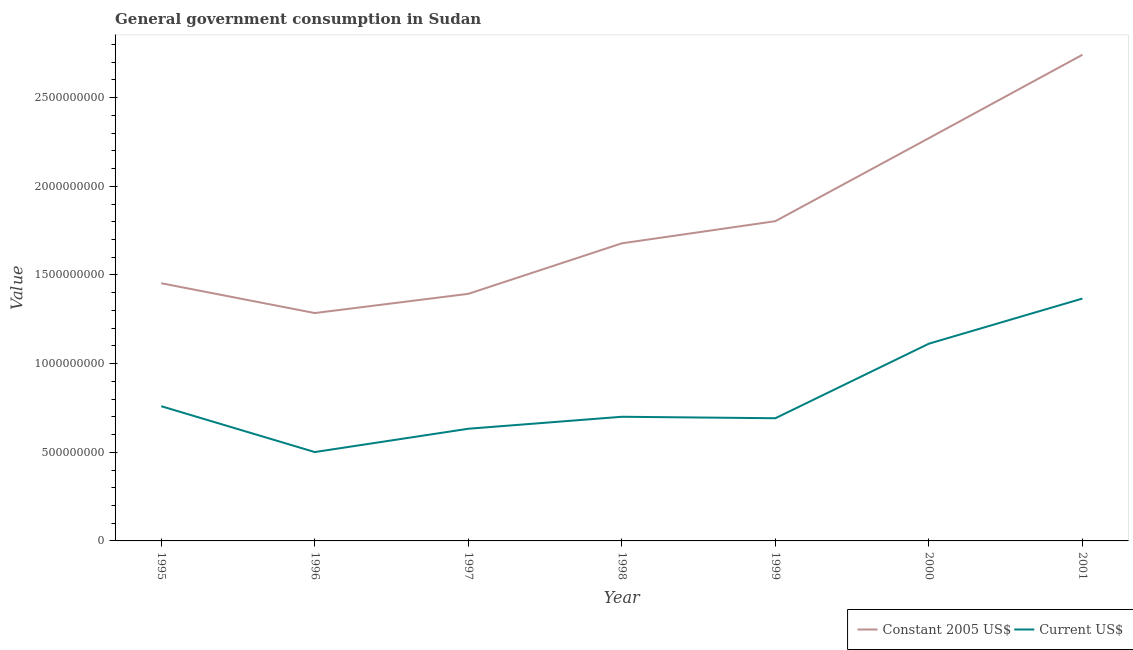How many different coloured lines are there?
Offer a terse response. 2. Does the line corresponding to value consumed in constant 2005 us$ intersect with the line corresponding to value consumed in current us$?
Ensure brevity in your answer.  No. What is the value consumed in current us$ in 1998?
Make the answer very short. 7.00e+08. Across all years, what is the maximum value consumed in current us$?
Your answer should be very brief. 1.37e+09. Across all years, what is the minimum value consumed in current us$?
Provide a short and direct response. 5.01e+08. In which year was the value consumed in current us$ maximum?
Ensure brevity in your answer.  2001. In which year was the value consumed in current us$ minimum?
Provide a short and direct response. 1996. What is the total value consumed in current us$ in the graph?
Your response must be concise. 5.77e+09. What is the difference between the value consumed in constant 2005 us$ in 1998 and that in 2001?
Your answer should be very brief. -1.06e+09. What is the difference between the value consumed in constant 2005 us$ in 1999 and the value consumed in current us$ in 1995?
Offer a very short reply. 1.04e+09. What is the average value consumed in current us$ per year?
Your response must be concise. 8.24e+08. In the year 1998, what is the difference between the value consumed in current us$ and value consumed in constant 2005 us$?
Provide a short and direct response. -9.78e+08. What is the ratio of the value consumed in current us$ in 1996 to that in 2001?
Offer a very short reply. 0.37. Is the difference between the value consumed in current us$ in 1995 and 1997 greater than the difference between the value consumed in constant 2005 us$ in 1995 and 1997?
Your response must be concise. Yes. What is the difference between the highest and the second highest value consumed in current us$?
Offer a terse response. 2.54e+08. What is the difference between the highest and the lowest value consumed in current us$?
Give a very brief answer. 8.66e+08. In how many years, is the value consumed in constant 2005 us$ greater than the average value consumed in constant 2005 us$ taken over all years?
Your answer should be compact. 2. Does the value consumed in constant 2005 us$ monotonically increase over the years?
Keep it short and to the point. No. Is the value consumed in current us$ strictly greater than the value consumed in constant 2005 us$ over the years?
Your response must be concise. No. How many lines are there?
Ensure brevity in your answer.  2. Does the graph contain any zero values?
Your answer should be very brief. No. How many legend labels are there?
Your answer should be compact. 2. How are the legend labels stacked?
Offer a terse response. Horizontal. What is the title of the graph?
Your answer should be compact. General government consumption in Sudan. What is the label or title of the Y-axis?
Keep it short and to the point. Value. What is the Value in Constant 2005 US$ in 1995?
Provide a short and direct response. 1.45e+09. What is the Value in Current US$ in 1995?
Make the answer very short. 7.60e+08. What is the Value of Constant 2005 US$ in 1996?
Keep it short and to the point. 1.29e+09. What is the Value in Current US$ in 1996?
Provide a succinct answer. 5.01e+08. What is the Value of Constant 2005 US$ in 1997?
Provide a short and direct response. 1.39e+09. What is the Value of Current US$ in 1997?
Offer a very short reply. 6.33e+08. What is the Value of Constant 2005 US$ in 1998?
Give a very brief answer. 1.68e+09. What is the Value in Current US$ in 1998?
Provide a succinct answer. 7.00e+08. What is the Value of Constant 2005 US$ in 1999?
Provide a short and direct response. 1.80e+09. What is the Value in Current US$ in 1999?
Ensure brevity in your answer.  6.92e+08. What is the Value in Constant 2005 US$ in 2000?
Give a very brief answer. 2.27e+09. What is the Value in Current US$ in 2000?
Give a very brief answer. 1.11e+09. What is the Value in Constant 2005 US$ in 2001?
Offer a terse response. 2.74e+09. What is the Value of Current US$ in 2001?
Your response must be concise. 1.37e+09. Across all years, what is the maximum Value of Constant 2005 US$?
Provide a short and direct response. 2.74e+09. Across all years, what is the maximum Value in Current US$?
Ensure brevity in your answer.  1.37e+09. Across all years, what is the minimum Value of Constant 2005 US$?
Your answer should be very brief. 1.29e+09. Across all years, what is the minimum Value in Current US$?
Your response must be concise. 5.01e+08. What is the total Value of Constant 2005 US$ in the graph?
Your answer should be compact. 1.26e+1. What is the total Value in Current US$ in the graph?
Give a very brief answer. 5.77e+09. What is the difference between the Value in Constant 2005 US$ in 1995 and that in 1996?
Provide a short and direct response. 1.68e+08. What is the difference between the Value in Current US$ in 1995 and that in 1996?
Your answer should be compact. 2.59e+08. What is the difference between the Value in Constant 2005 US$ in 1995 and that in 1997?
Your answer should be very brief. 5.98e+07. What is the difference between the Value in Current US$ in 1995 and that in 1997?
Keep it short and to the point. 1.27e+08. What is the difference between the Value in Constant 2005 US$ in 1995 and that in 1998?
Give a very brief answer. -2.25e+08. What is the difference between the Value in Current US$ in 1995 and that in 1998?
Your response must be concise. 5.95e+07. What is the difference between the Value in Constant 2005 US$ in 1995 and that in 1999?
Your response must be concise. -3.50e+08. What is the difference between the Value of Current US$ in 1995 and that in 1999?
Offer a very short reply. 6.78e+07. What is the difference between the Value of Constant 2005 US$ in 1995 and that in 2000?
Make the answer very short. -8.18e+08. What is the difference between the Value in Current US$ in 1995 and that in 2000?
Ensure brevity in your answer.  -3.53e+08. What is the difference between the Value of Constant 2005 US$ in 1995 and that in 2001?
Give a very brief answer. -1.29e+09. What is the difference between the Value in Current US$ in 1995 and that in 2001?
Your answer should be compact. -6.07e+08. What is the difference between the Value in Constant 2005 US$ in 1996 and that in 1997?
Provide a succinct answer. -1.08e+08. What is the difference between the Value in Current US$ in 1996 and that in 1997?
Provide a short and direct response. -1.31e+08. What is the difference between the Value in Constant 2005 US$ in 1996 and that in 1998?
Make the answer very short. -3.93e+08. What is the difference between the Value of Current US$ in 1996 and that in 1998?
Keep it short and to the point. -1.99e+08. What is the difference between the Value of Constant 2005 US$ in 1996 and that in 1999?
Keep it short and to the point. -5.18e+08. What is the difference between the Value in Current US$ in 1996 and that in 1999?
Your answer should be very brief. -1.91e+08. What is the difference between the Value of Constant 2005 US$ in 1996 and that in 2000?
Keep it short and to the point. -9.87e+08. What is the difference between the Value in Current US$ in 1996 and that in 2000?
Make the answer very short. -6.11e+08. What is the difference between the Value in Constant 2005 US$ in 1996 and that in 2001?
Your answer should be compact. -1.46e+09. What is the difference between the Value of Current US$ in 1996 and that in 2001?
Offer a very short reply. -8.66e+08. What is the difference between the Value in Constant 2005 US$ in 1997 and that in 1998?
Ensure brevity in your answer.  -2.85e+08. What is the difference between the Value in Current US$ in 1997 and that in 1998?
Your answer should be compact. -6.76e+07. What is the difference between the Value in Constant 2005 US$ in 1997 and that in 1999?
Provide a succinct answer. -4.10e+08. What is the difference between the Value in Current US$ in 1997 and that in 1999?
Give a very brief answer. -5.93e+07. What is the difference between the Value in Constant 2005 US$ in 1997 and that in 2000?
Offer a terse response. -8.78e+08. What is the difference between the Value in Current US$ in 1997 and that in 2000?
Keep it short and to the point. -4.80e+08. What is the difference between the Value in Constant 2005 US$ in 1997 and that in 2001?
Give a very brief answer. -1.35e+09. What is the difference between the Value in Current US$ in 1997 and that in 2001?
Make the answer very short. -7.34e+08. What is the difference between the Value of Constant 2005 US$ in 1998 and that in 1999?
Offer a very short reply. -1.25e+08. What is the difference between the Value in Current US$ in 1998 and that in 1999?
Your answer should be very brief. 8.26e+06. What is the difference between the Value in Constant 2005 US$ in 1998 and that in 2000?
Offer a terse response. -5.93e+08. What is the difference between the Value in Current US$ in 1998 and that in 2000?
Your response must be concise. -4.12e+08. What is the difference between the Value of Constant 2005 US$ in 1998 and that in 2001?
Ensure brevity in your answer.  -1.06e+09. What is the difference between the Value of Current US$ in 1998 and that in 2001?
Give a very brief answer. -6.67e+08. What is the difference between the Value in Constant 2005 US$ in 1999 and that in 2000?
Your response must be concise. -4.68e+08. What is the difference between the Value of Current US$ in 1999 and that in 2000?
Offer a terse response. -4.21e+08. What is the difference between the Value in Constant 2005 US$ in 1999 and that in 2001?
Your answer should be very brief. -9.39e+08. What is the difference between the Value in Current US$ in 1999 and that in 2001?
Provide a succinct answer. -6.75e+08. What is the difference between the Value in Constant 2005 US$ in 2000 and that in 2001?
Offer a terse response. -4.70e+08. What is the difference between the Value in Current US$ in 2000 and that in 2001?
Keep it short and to the point. -2.54e+08. What is the difference between the Value of Constant 2005 US$ in 1995 and the Value of Current US$ in 1996?
Offer a terse response. 9.52e+08. What is the difference between the Value in Constant 2005 US$ in 1995 and the Value in Current US$ in 1997?
Give a very brief answer. 8.21e+08. What is the difference between the Value in Constant 2005 US$ in 1995 and the Value in Current US$ in 1998?
Offer a very short reply. 7.53e+08. What is the difference between the Value of Constant 2005 US$ in 1995 and the Value of Current US$ in 1999?
Your response must be concise. 7.61e+08. What is the difference between the Value of Constant 2005 US$ in 1995 and the Value of Current US$ in 2000?
Provide a short and direct response. 3.41e+08. What is the difference between the Value of Constant 2005 US$ in 1995 and the Value of Current US$ in 2001?
Offer a terse response. 8.64e+07. What is the difference between the Value of Constant 2005 US$ in 1996 and the Value of Current US$ in 1997?
Your answer should be compact. 6.53e+08. What is the difference between the Value in Constant 2005 US$ in 1996 and the Value in Current US$ in 1998?
Provide a short and direct response. 5.85e+08. What is the difference between the Value in Constant 2005 US$ in 1996 and the Value in Current US$ in 1999?
Offer a very short reply. 5.93e+08. What is the difference between the Value in Constant 2005 US$ in 1996 and the Value in Current US$ in 2000?
Offer a very short reply. 1.73e+08. What is the difference between the Value of Constant 2005 US$ in 1996 and the Value of Current US$ in 2001?
Provide a short and direct response. -8.18e+07. What is the difference between the Value in Constant 2005 US$ in 1997 and the Value in Current US$ in 1998?
Your answer should be compact. 6.93e+08. What is the difference between the Value in Constant 2005 US$ in 1997 and the Value in Current US$ in 1999?
Offer a very short reply. 7.02e+08. What is the difference between the Value in Constant 2005 US$ in 1997 and the Value in Current US$ in 2000?
Your answer should be compact. 2.81e+08. What is the difference between the Value of Constant 2005 US$ in 1997 and the Value of Current US$ in 2001?
Provide a succinct answer. 2.65e+07. What is the difference between the Value of Constant 2005 US$ in 1998 and the Value of Current US$ in 1999?
Offer a very short reply. 9.87e+08. What is the difference between the Value in Constant 2005 US$ in 1998 and the Value in Current US$ in 2000?
Provide a short and direct response. 5.66e+08. What is the difference between the Value of Constant 2005 US$ in 1998 and the Value of Current US$ in 2001?
Keep it short and to the point. 3.11e+08. What is the difference between the Value in Constant 2005 US$ in 1999 and the Value in Current US$ in 2000?
Ensure brevity in your answer.  6.91e+08. What is the difference between the Value of Constant 2005 US$ in 1999 and the Value of Current US$ in 2001?
Your response must be concise. 4.36e+08. What is the difference between the Value in Constant 2005 US$ in 2000 and the Value in Current US$ in 2001?
Make the answer very short. 9.05e+08. What is the average Value in Constant 2005 US$ per year?
Ensure brevity in your answer.  1.80e+09. What is the average Value of Current US$ per year?
Offer a very short reply. 8.24e+08. In the year 1995, what is the difference between the Value in Constant 2005 US$ and Value in Current US$?
Provide a short and direct response. 6.94e+08. In the year 1996, what is the difference between the Value in Constant 2005 US$ and Value in Current US$?
Your answer should be very brief. 7.84e+08. In the year 1997, what is the difference between the Value in Constant 2005 US$ and Value in Current US$?
Offer a very short reply. 7.61e+08. In the year 1998, what is the difference between the Value of Constant 2005 US$ and Value of Current US$?
Provide a short and direct response. 9.78e+08. In the year 1999, what is the difference between the Value of Constant 2005 US$ and Value of Current US$?
Make the answer very short. 1.11e+09. In the year 2000, what is the difference between the Value in Constant 2005 US$ and Value in Current US$?
Your answer should be very brief. 1.16e+09. In the year 2001, what is the difference between the Value of Constant 2005 US$ and Value of Current US$?
Your answer should be compact. 1.38e+09. What is the ratio of the Value in Constant 2005 US$ in 1995 to that in 1996?
Your answer should be very brief. 1.13. What is the ratio of the Value of Current US$ in 1995 to that in 1996?
Your answer should be compact. 1.52. What is the ratio of the Value of Constant 2005 US$ in 1995 to that in 1997?
Your response must be concise. 1.04. What is the ratio of the Value in Current US$ in 1995 to that in 1997?
Make the answer very short. 1.2. What is the ratio of the Value of Constant 2005 US$ in 1995 to that in 1998?
Provide a short and direct response. 0.87. What is the ratio of the Value of Current US$ in 1995 to that in 1998?
Your answer should be compact. 1.08. What is the ratio of the Value of Constant 2005 US$ in 1995 to that in 1999?
Offer a very short reply. 0.81. What is the ratio of the Value of Current US$ in 1995 to that in 1999?
Your answer should be compact. 1.1. What is the ratio of the Value in Constant 2005 US$ in 1995 to that in 2000?
Your answer should be compact. 0.64. What is the ratio of the Value of Current US$ in 1995 to that in 2000?
Provide a succinct answer. 0.68. What is the ratio of the Value in Constant 2005 US$ in 1995 to that in 2001?
Ensure brevity in your answer.  0.53. What is the ratio of the Value in Current US$ in 1995 to that in 2001?
Provide a short and direct response. 0.56. What is the ratio of the Value in Constant 2005 US$ in 1996 to that in 1997?
Give a very brief answer. 0.92. What is the ratio of the Value in Current US$ in 1996 to that in 1997?
Ensure brevity in your answer.  0.79. What is the ratio of the Value of Constant 2005 US$ in 1996 to that in 1998?
Your response must be concise. 0.77. What is the ratio of the Value of Current US$ in 1996 to that in 1998?
Ensure brevity in your answer.  0.72. What is the ratio of the Value of Constant 2005 US$ in 1996 to that in 1999?
Provide a succinct answer. 0.71. What is the ratio of the Value of Current US$ in 1996 to that in 1999?
Keep it short and to the point. 0.72. What is the ratio of the Value in Constant 2005 US$ in 1996 to that in 2000?
Your response must be concise. 0.57. What is the ratio of the Value in Current US$ in 1996 to that in 2000?
Provide a short and direct response. 0.45. What is the ratio of the Value in Constant 2005 US$ in 1996 to that in 2001?
Offer a terse response. 0.47. What is the ratio of the Value in Current US$ in 1996 to that in 2001?
Your answer should be compact. 0.37. What is the ratio of the Value in Constant 2005 US$ in 1997 to that in 1998?
Provide a succinct answer. 0.83. What is the ratio of the Value in Current US$ in 1997 to that in 1998?
Make the answer very short. 0.9. What is the ratio of the Value of Constant 2005 US$ in 1997 to that in 1999?
Give a very brief answer. 0.77. What is the ratio of the Value of Current US$ in 1997 to that in 1999?
Offer a terse response. 0.91. What is the ratio of the Value of Constant 2005 US$ in 1997 to that in 2000?
Offer a very short reply. 0.61. What is the ratio of the Value of Current US$ in 1997 to that in 2000?
Make the answer very short. 0.57. What is the ratio of the Value of Constant 2005 US$ in 1997 to that in 2001?
Ensure brevity in your answer.  0.51. What is the ratio of the Value in Current US$ in 1997 to that in 2001?
Your answer should be compact. 0.46. What is the ratio of the Value in Constant 2005 US$ in 1998 to that in 1999?
Give a very brief answer. 0.93. What is the ratio of the Value in Current US$ in 1998 to that in 1999?
Provide a short and direct response. 1.01. What is the ratio of the Value in Constant 2005 US$ in 1998 to that in 2000?
Offer a very short reply. 0.74. What is the ratio of the Value in Current US$ in 1998 to that in 2000?
Your response must be concise. 0.63. What is the ratio of the Value of Constant 2005 US$ in 1998 to that in 2001?
Offer a terse response. 0.61. What is the ratio of the Value in Current US$ in 1998 to that in 2001?
Provide a short and direct response. 0.51. What is the ratio of the Value in Constant 2005 US$ in 1999 to that in 2000?
Provide a short and direct response. 0.79. What is the ratio of the Value in Current US$ in 1999 to that in 2000?
Provide a short and direct response. 0.62. What is the ratio of the Value of Constant 2005 US$ in 1999 to that in 2001?
Your answer should be very brief. 0.66. What is the ratio of the Value of Current US$ in 1999 to that in 2001?
Your answer should be very brief. 0.51. What is the ratio of the Value in Constant 2005 US$ in 2000 to that in 2001?
Offer a terse response. 0.83. What is the ratio of the Value in Current US$ in 2000 to that in 2001?
Provide a short and direct response. 0.81. What is the difference between the highest and the second highest Value in Constant 2005 US$?
Provide a short and direct response. 4.70e+08. What is the difference between the highest and the second highest Value of Current US$?
Offer a very short reply. 2.54e+08. What is the difference between the highest and the lowest Value in Constant 2005 US$?
Your response must be concise. 1.46e+09. What is the difference between the highest and the lowest Value in Current US$?
Ensure brevity in your answer.  8.66e+08. 